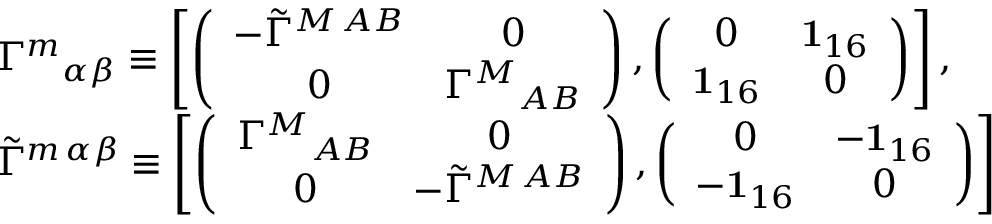Convert formula to latex. <formula><loc_0><loc_0><loc_500><loc_500>\begin{array} { l } { { { \Gamma ^ { m } } _ { \alpha \beta } \equiv \left [ \left ( \begin{array} { c c } { { - \tilde { \Gamma } ^ { M \, A B } } } & { 0 } \\ { 0 } & { { { \Gamma ^ { M } } _ { A B } } } \end{array} \right ) , \left ( \begin{array} { c c } { 0 } & { { { 1 } _ { 1 6 } } } \\ { { { 1 } _ { 1 6 } } } & { 0 } \end{array} \right ) \right ] , } } \\ { { \tilde { \Gamma } ^ { m \, \alpha \beta } \equiv \left [ \left ( \begin{array} { c c } { { { \Gamma ^ { M } } _ { A B } } } & { 0 } \\ { 0 } & { { - \tilde { \Gamma } ^ { M \, A B } } } \end{array} \right ) , \left ( \begin{array} { c c } { 0 } & { { - { 1 } _ { 1 6 } } } \\ { { - { 1 } _ { 1 6 } } } & { 0 } \end{array} \right ) \right ] } } \end{array}</formula> 